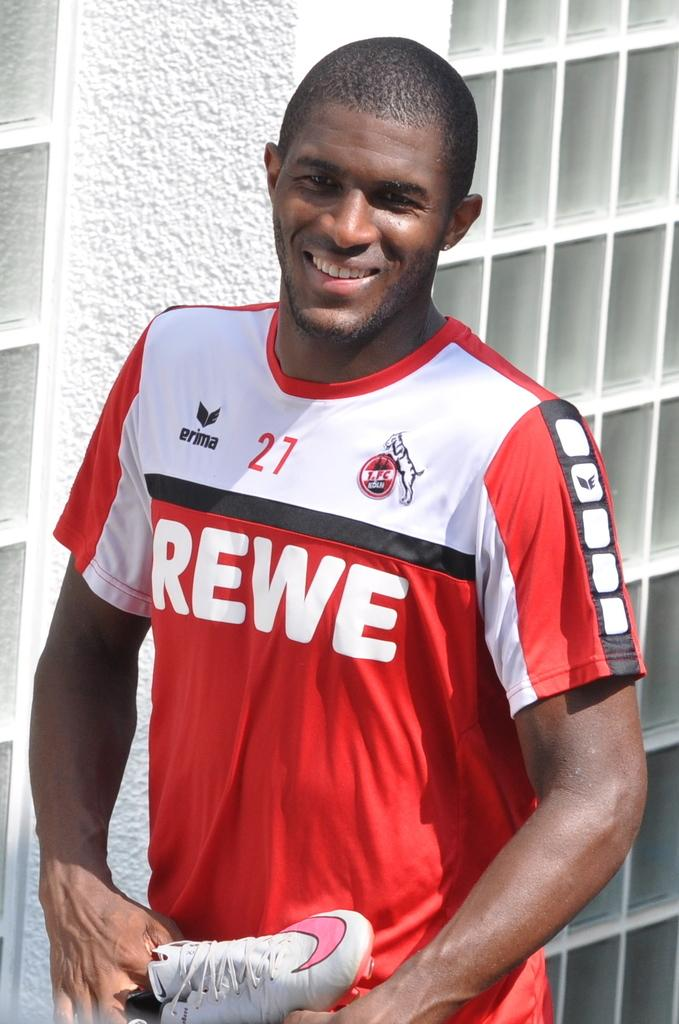<image>
Summarize the visual content of the image. Number 27 for REWE is printed on this sport's jersey. 